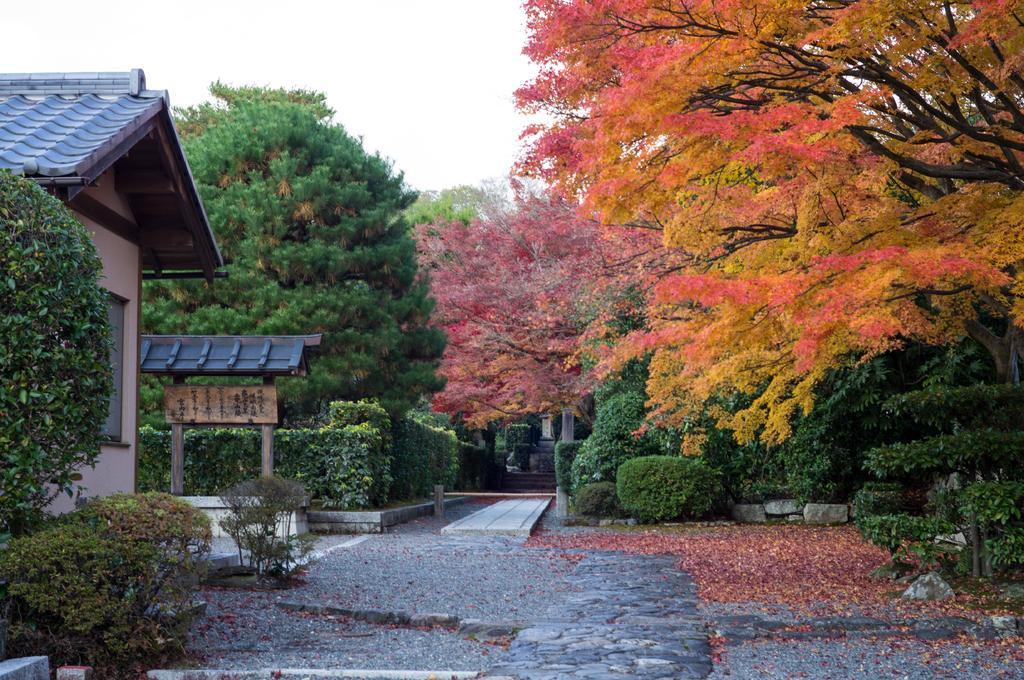What type of vegetation can be seen in the image? There are trees and garden plants in the image. What is on the ground in the image? There are leaves on the ground in the image. What architectural features are present in the image? There are pillars, a building, and a small arch in the image. What part of the natural environment is visible in the image? The sky is visible in the image. What type of furniture is being taught in the image? There is no furniture or teaching activity present in the image. What is causing the throat irritation in the image? There is no indication of throat irritation or any related issues in the image. 